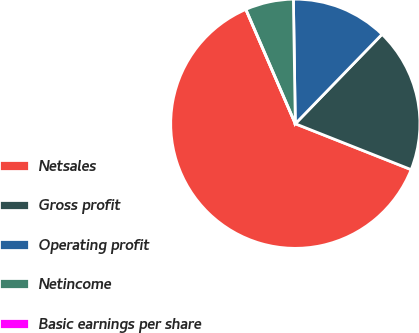<chart> <loc_0><loc_0><loc_500><loc_500><pie_chart><fcel>Netsales<fcel>Gross profit<fcel>Operating profit<fcel>Netincome<fcel>Basic earnings per share<nl><fcel>62.5%<fcel>18.75%<fcel>12.5%<fcel>6.25%<fcel>0.0%<nl></chart> 